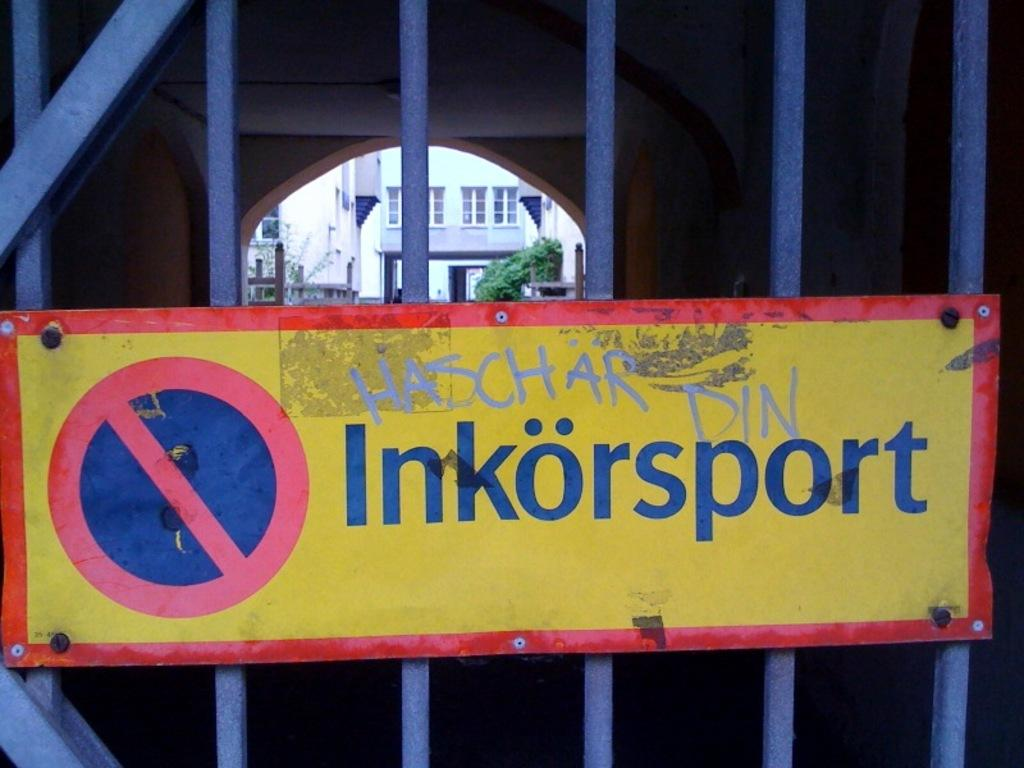What is the main object in the center of the image? There is a sign board in the center of the image. Where is the sign board located? The sign board is on a gate. What can be seen in the background of the image? There are buildings and greenery in the background of the image. Can you tell me what type of camera is being used by the grandmother in the image? There is no camera or grandmother present in the image. 